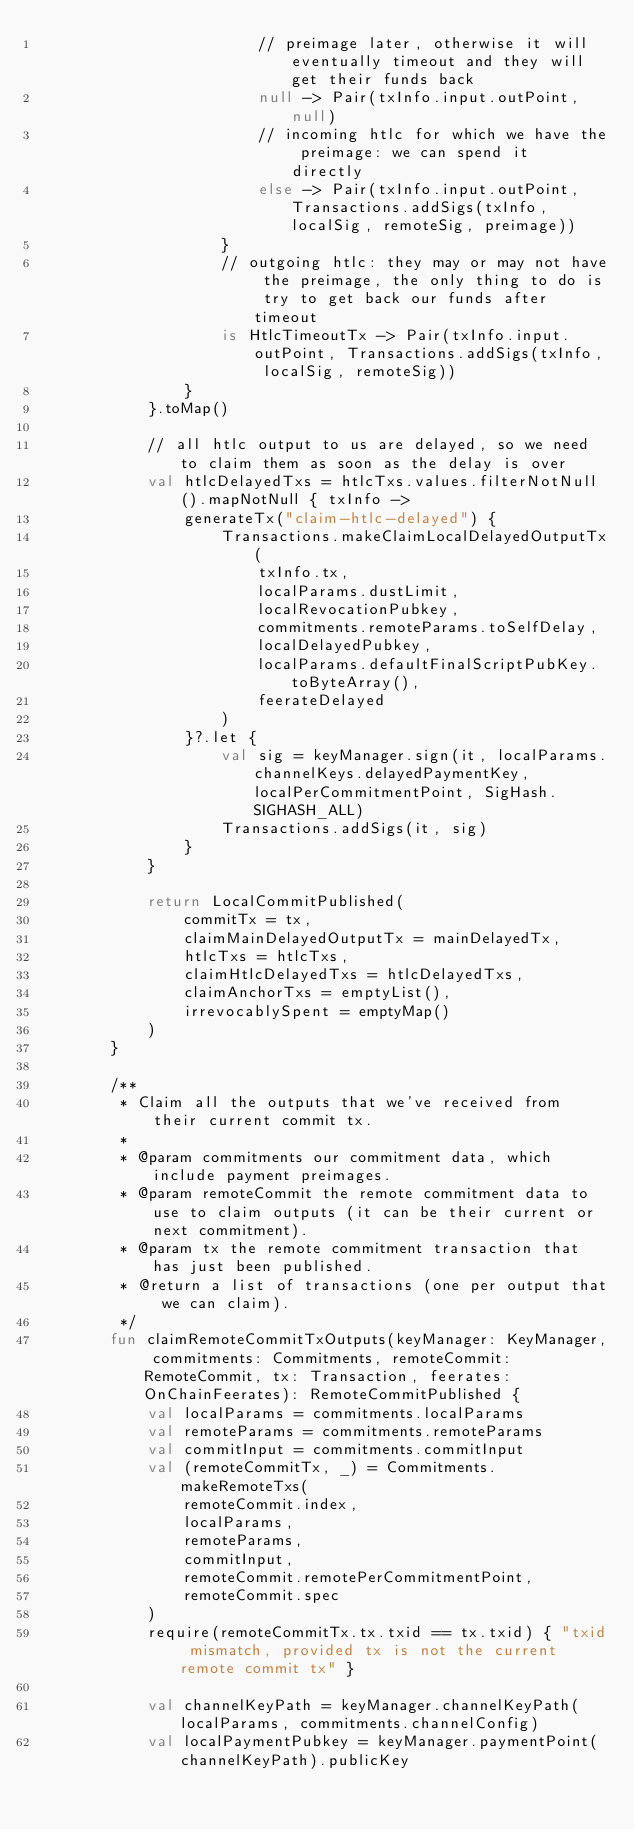Convert code to text. <code><loc_0><loc_0><loc_500><loc_500><_Kotlin_>                        // preimage later, otherwise it will eventually timeout and they will get their funds back
                        null -> Pair(txInfo.input.outPoint, null)
                        // incoming htlc for which we have the preimage: we can spend it directly
                        else -> Pair(txInfo.input.outPoint, Transactions.addSigs(txInfo, localSig, remoteSig, preimage))
                    }
                    // outgoing htlc: they may or may not have the preimage, the only thing to do is try to get back our funds after timeout
                    is HtlcTimeoutTx -> Pair(txInfo.input.outPoint, Transactions.addSigs(txInfo, localSig, remoteSig))
                }
            }.toMap()

            // all htlc output to us are delayed, so we need to claim them as soon as the delay is over
            val htlcDelayedTxs = htlcTxs.values.filterNotNull().mapNotNull { txInfo ->
                generateTx("claim-htlc-delayed") {
                    Transactions.makeClaimLocalDelayedOutputTx(
                        txInfo.tx,
                        localParams.dustLimit,
                        localRevocationPubkey,
                        commitments.remoteParams.toSelfDelay,
                        localDelayedPubkey,
                        localParams.defaultFinalScriptPubKey.toByteArray(),
                        feerateDelayed
                    )
                }?.let {
                    val sig = keyManager.sign(it, localParams.channelKeys.delayedPaymentKey, localPerCommitmentPoint, SigHash.SIGHASH_ALL)
                    Transactions.addSigs(it, sig)
                }
            }

            return LocalCommitPublished(
                commitTx = tx,
                claimMainDelayedOutputTx = mainDelayedTx,
                htlcTxs = htlcTxs,
                claimHtlcDelayedTxs = htlcDelayedTxs,
                claimAnchorTxs = emptyList(),
                irrevocablySpent = emptyMap()
            )
        }

        /**
         * Claim all the outputs that we've received from their current commit tx.
         *
         * @param commitments our commitment data, which include payment preimages.
         * @param remoteCommit the remote commitment data to use to claim outputs (it can be their current or next commitment).
         * @param tx the remote commitment transaction that has just been published.
         * @return a list of transactions (one per output that we can claim).
         */
        fun claimRemoteCommitTxOutputs(keyManager: KeyManager, commitments: Commitments, remoteCommit: RemoteCommit, tx: Transaction, feerates: OnChainFeerates): RemoteCommitPublished {
            val localParams = commitments.localParams
            val remoteParams = commitments.remoteParams
            val commitInput = commitments.commitInput
            val (remoteCommitTx, _) = Commitments.makeRemoteTxs(
                remoteCommit.index,
                localParams,
                remoteParams,
                commitInput,
                remoteCommit.remotePerCommitmentPoint,
                remoteCommit.spec
            )
            require(remoteCommitTx.tx.txid == tx.txid) { "txid mismatch, provided tx is not the current remote commit tx" }

            val channelKeyPath = keyManager.channelKeyPath(localParams, commitments.channelConfig)
            val localPaymentPubkey = keyManager.paymentPoint(channelKeyPath).publicKey</code> 